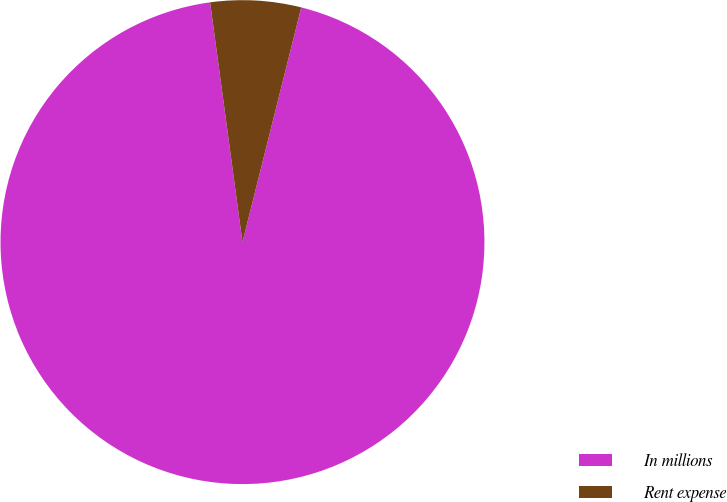Convert chart. <chart><loc_0><loc_0><loc_500><loc_500><pie_chart><fcel>In millions<fcel>Rent expense<nl><fcel>93.96%<fcel>6.04%<nl></chart> 